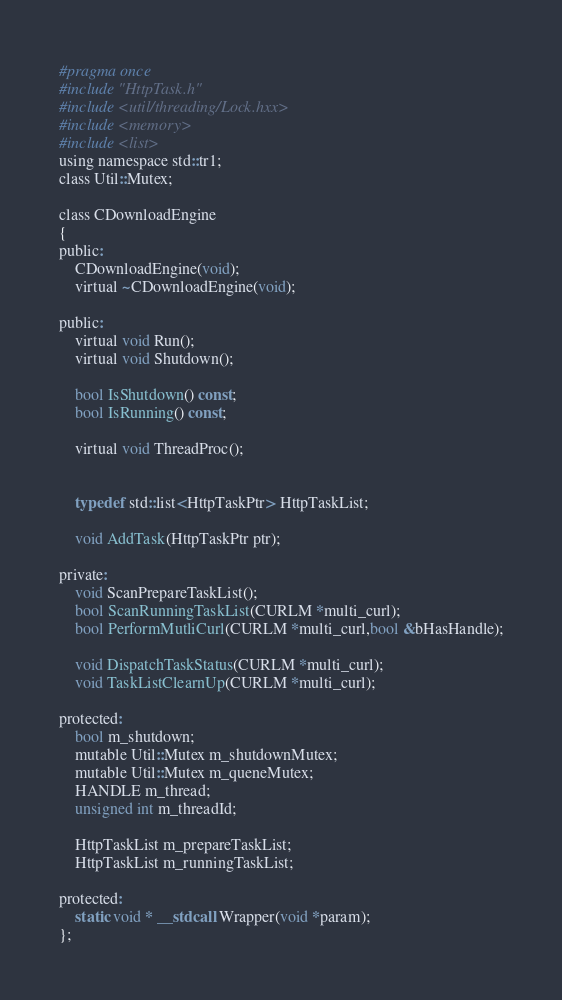<code> <loc_0><loc_0><loc_500><loc_500><_C_>#pragma once
#include "HttpTask.h"
#include <util/threading/Lock.hxx>
#include <memory>
#include <list>
using namespace std::tr1;
class Util::Mutex;

class CDownloadEngine
{
public:
	CDownloadEngine(void);
	virtual ~CDownloadEngine(void);

public:
	virtual void Run();
	virtual void Shutdown();

	bool IsShutdown() const;
	bool IsRunning() const;

	virtual void ThreadProc();

	
	typedef std::list<HttpTaskPtr> HttpTaskList;

	void AddTask(HttpTaskPtr ptr);

private:
	void ScanPrepareTaskList();
	bool ScanRunningTaskList(CURLM *multi_curl);
	bool PerformMutliCurl(CURLM *multi_curl,bool &bHasHandle);

	void DispatchTaskStatus(CURLM *multi_curl);
	void TaskListClearnUp(CURLM *multi_curl);

protected:
	bool m_shutdown;
	mutable Util::Mutex m_shutdownMutex;
	mutable Util::Mutex m_queneMutex;
	HANDLE m_thread;
	unsigned int m_threadId;

	HttpTaskList m_prepareTaskList;
	HttpTaskList m_runningTaskList;

protected:
	static void * __stdcall Wrapper(void *param);
};
</code> 